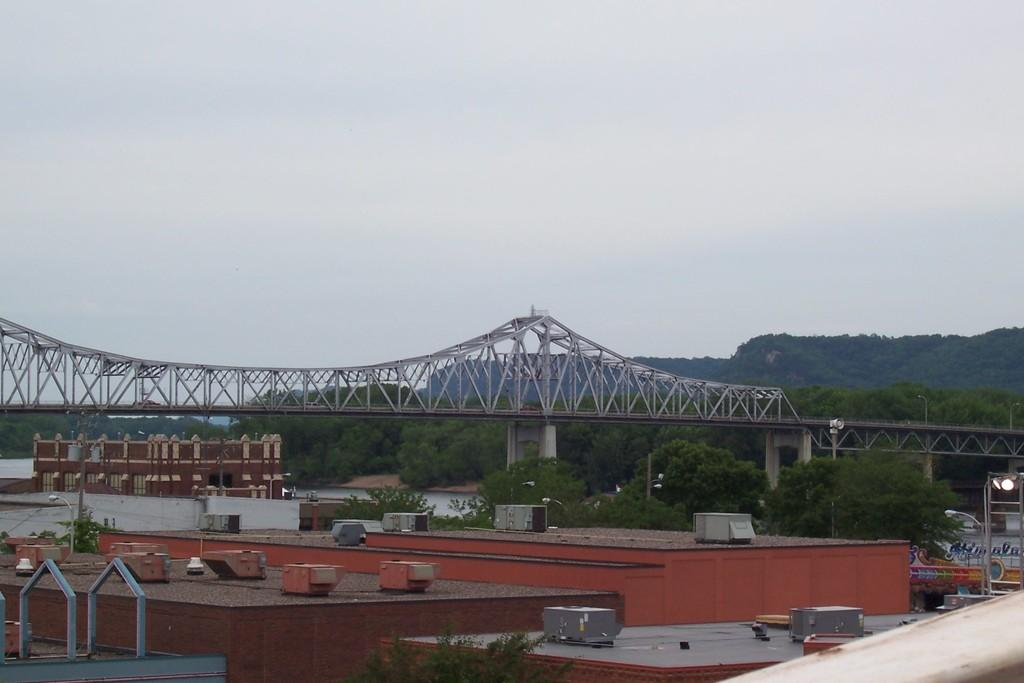What is located on the roof tops in the image? There are objects on roof tops in the image. What can be seen sticking up in the image? There are rods visible in the image. What type of plant life is present in the image? There is a tree in the image. What type of structure can be seen crossing a body of water? There is a bridge in the image. What can be used to provide illumination in the image? There are lights in the image. What type of structures are visible in the background of the image? There are buildings and trees in the background of the image. What type of lighting is present in the background of the image? There are lights on poles in the background of the image. What part of the natural environment is visible in the background of the image? The sky is visible in the background of the image. Can you tell me how many oranges are hanging from the tree in the image? There are no oranges present in the image; it features a tree without any visible fruit. What type of trouble is the bridge causing in the image? There is no indication of any trouble with the bridge in the image; it appears to be a normal, functioning structure. 